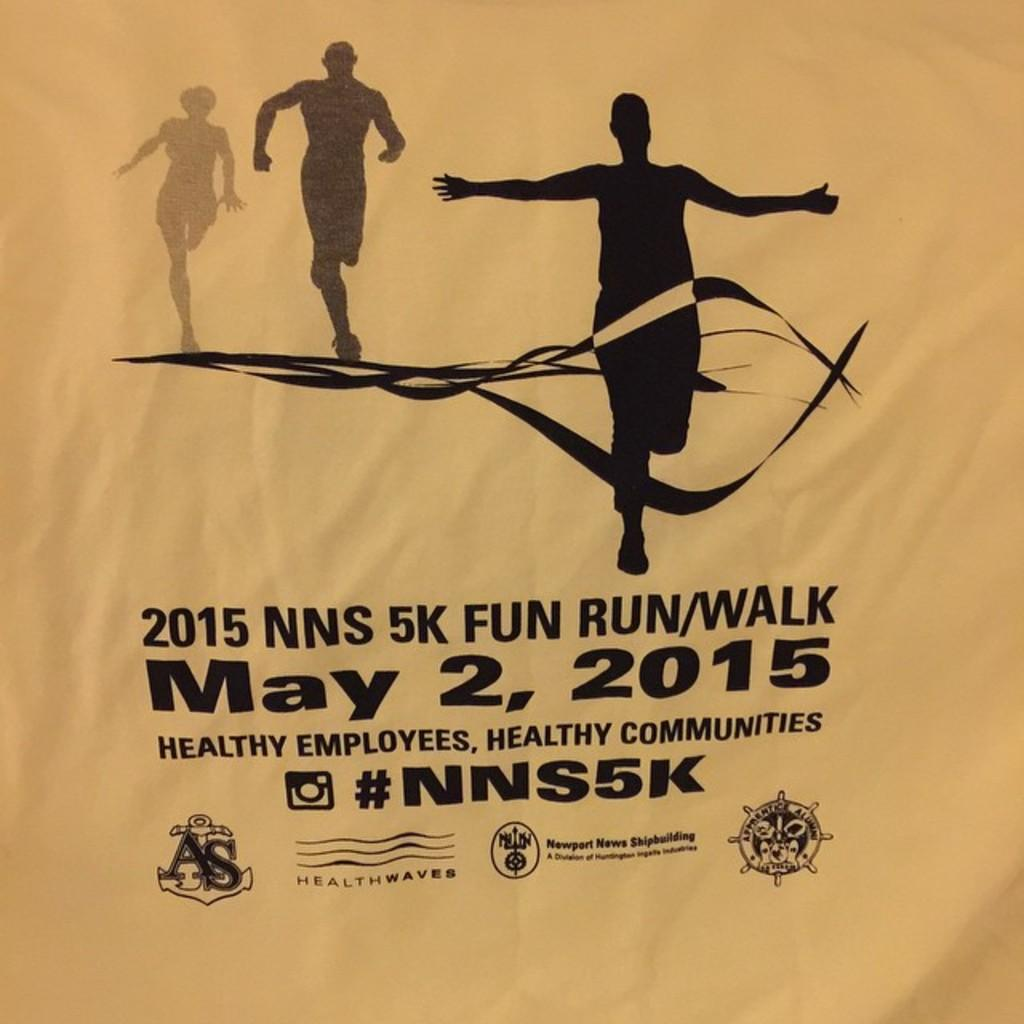What is depicted on the cloth in the image? There is a painting on a cloth in the image. What activity can be seen in the background of the image? There are people running in the background of the image. What information is provided at the bottom of the image? There is text written at the bottom of the image. How many babies are crawling on the field in the image? There are no babies or fields present in the image. 